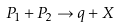<formula> <loc_0><loc_0><loc_500><loc_500>P _ { 1 } + P _ { 2 } \rightarrow q + X</formula> 